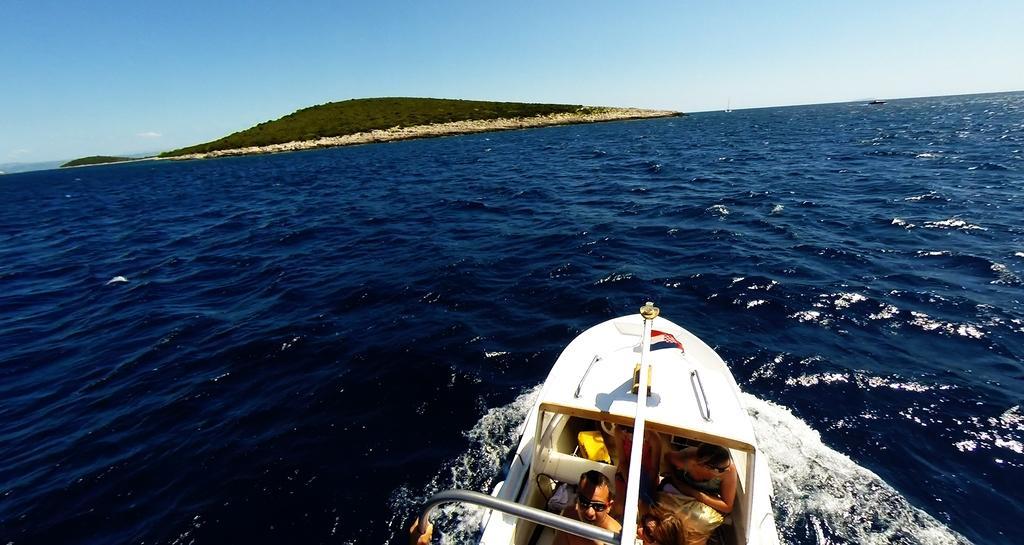Describe this image in one or two sentences. There are few people riding on the boat on the water. In the background there are trees,mountain and sky. 